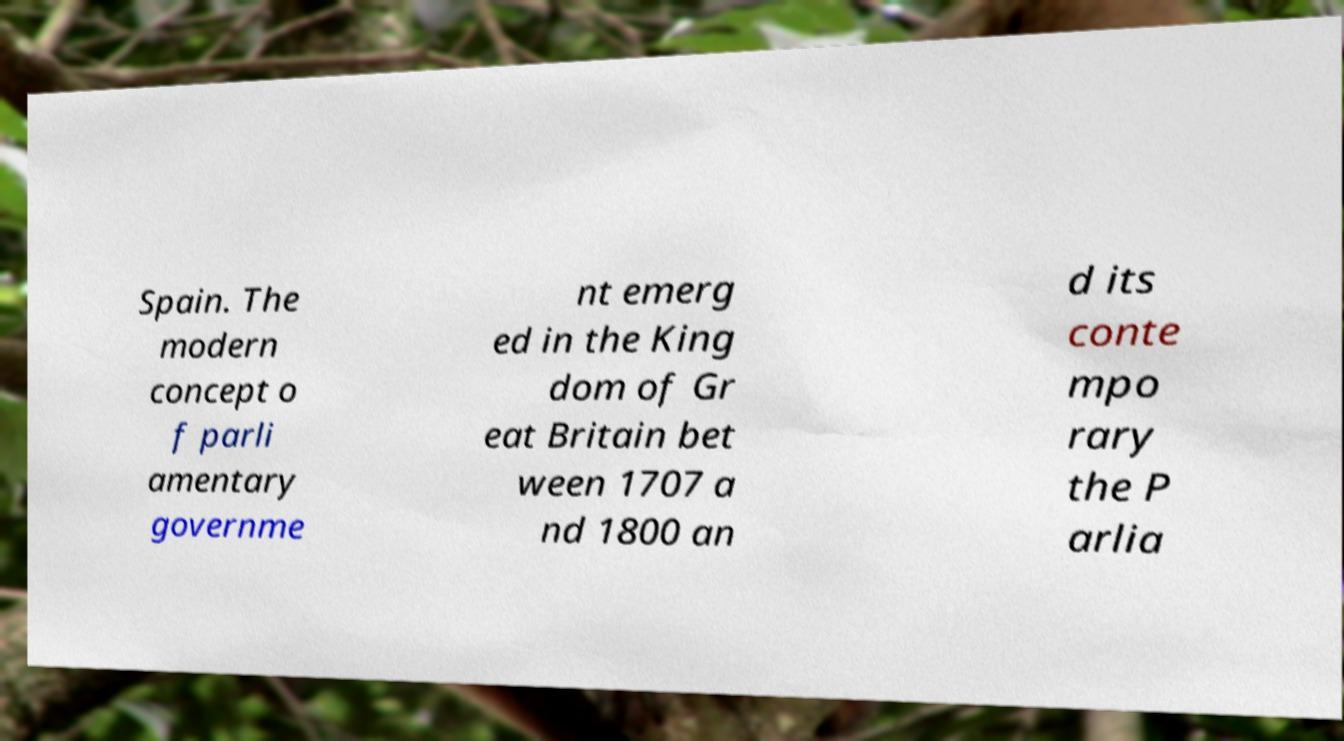I need the written content from this picture converted into text. Can you do that? Spain. The modern concept o f parli amentary governme nt emerg ed in the King dom of Gr eat Britain bet ween 1707 a nd 1800 an d its conte mpo rary the P arlia 